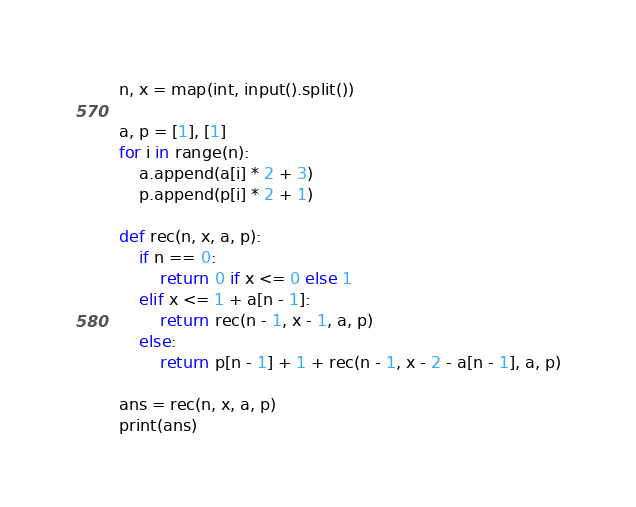<code> <loc_0><loc_0><loc_500><loc_500><_Python_>n, x = map(int, input().split())

a, p = [1], [1]
for i in range(n):
    a.append(a[i] * 2 + 3)
    p.append(p[i] * 2 + 1)

def rec(n, x, a, p):
    if n == 0:
        return 0 if x <= 0 else 1
    elif x <= 1 + a[n - 1]:
        return rec(n - 1, x - 1, a, p)
    else:
        return p[n - 1] + 1 + rec(n - 1, x - 2 - a[n - 1], a, p)

ans = rec(n, x, a, p)
print(ans)</code> 